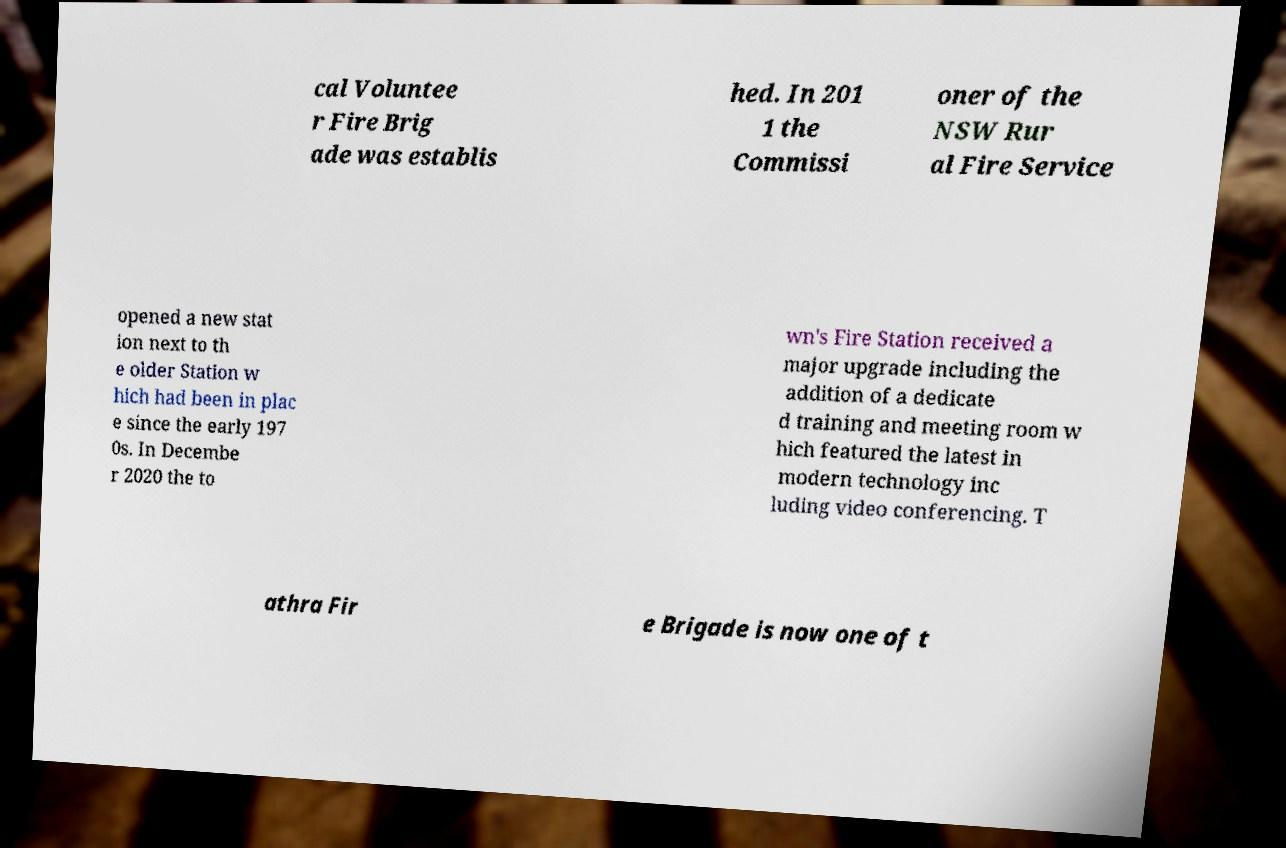I need the written content from this picture converted into text. Can you do that? cal Voluntee r Fire Brig ade was establis hed. In 201 1 the Commissi oner of the NSW Rur al Fire Service opened a new stat ion next to th e older Station w hich had been in plac e since the early 197 0s. In Decembe r 2020 the to wn's Fire Station received a major upgrade including the addition of a dedicate d training and meeting room w hich featured the latest in modern technology inc luding video conferencing. T athra Fir e Brigade is now one of t 